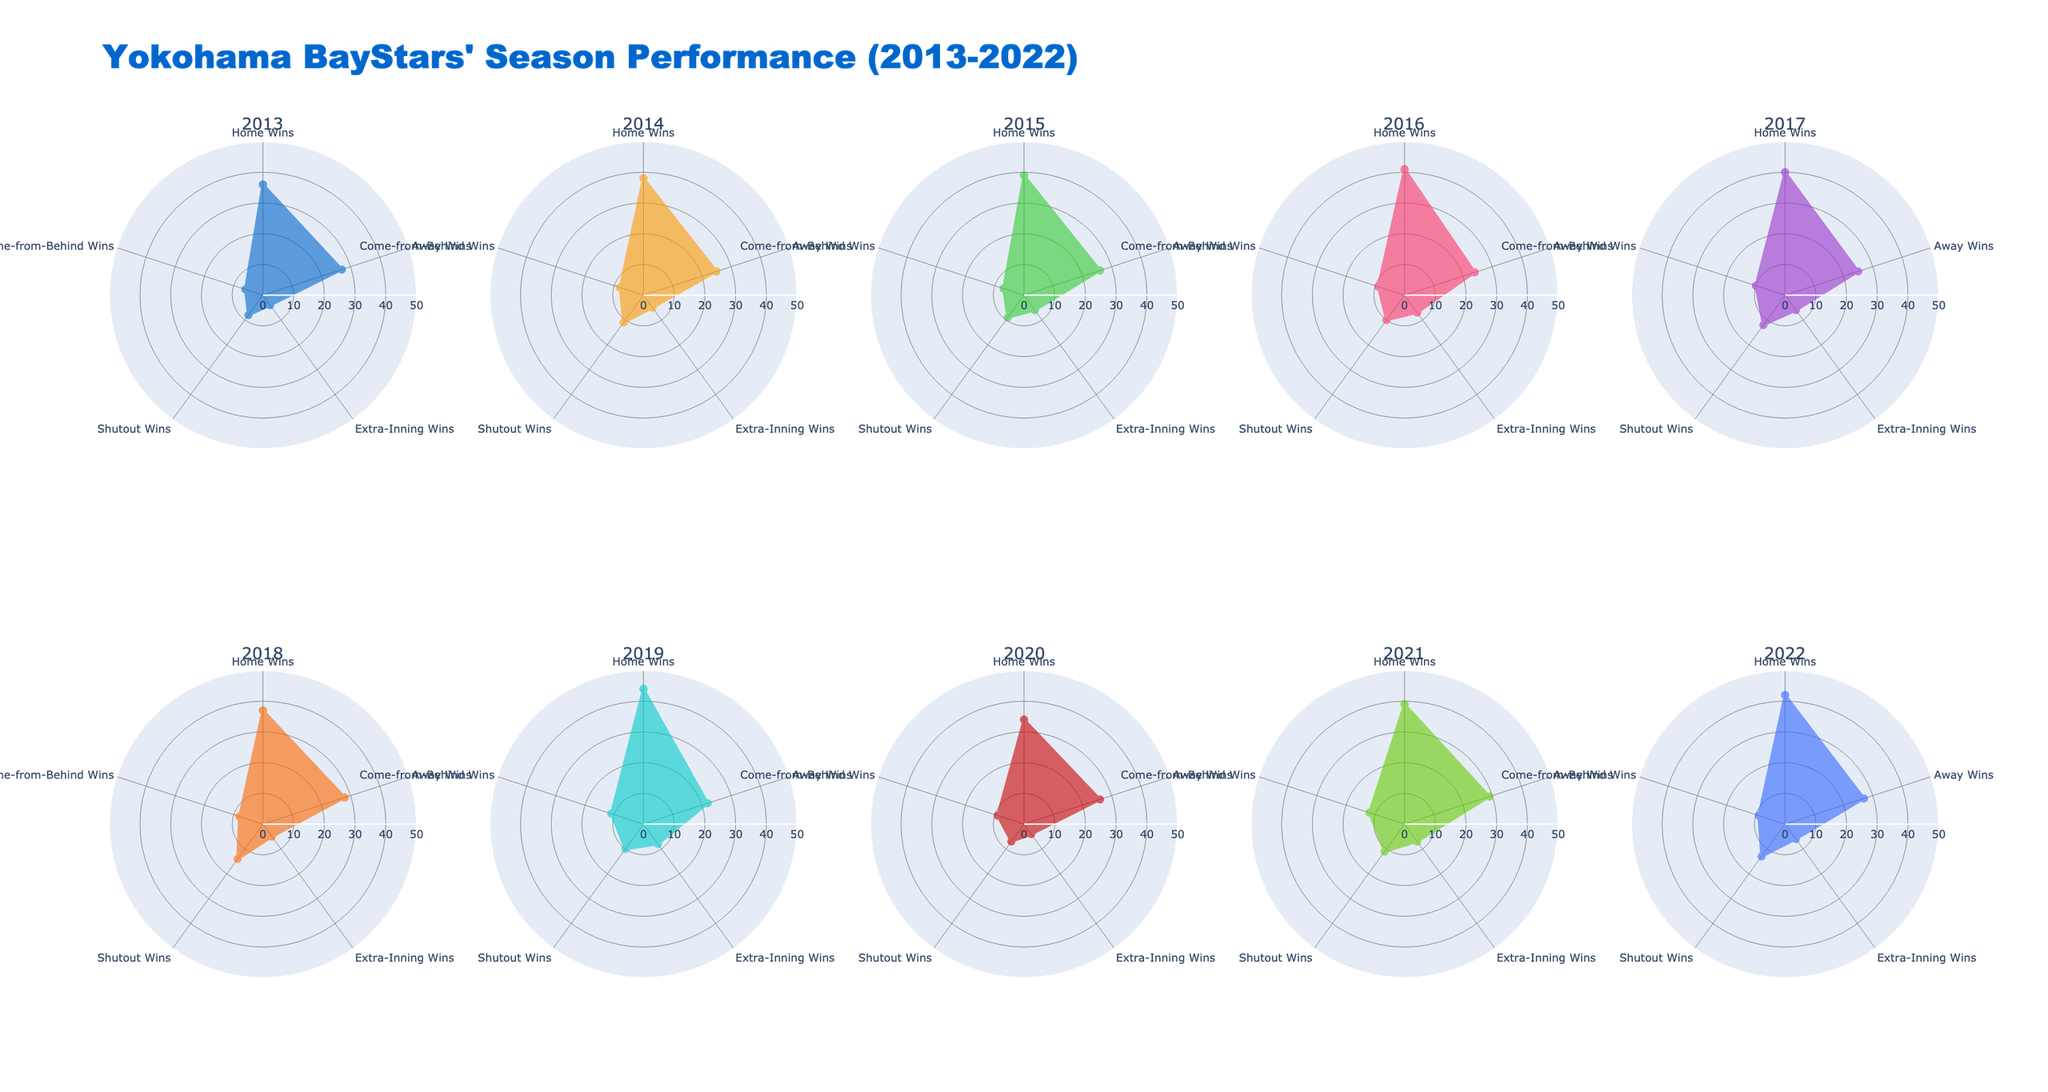What is the title of the figure? The title is prominently displayed at the top of the figure. It summarizes the overall content of the visualized data.
Answer: Yokohama BayStars' Season Performance (2013-2022) Which season had the highest number of Home Wins? By examining the individual radar charts, we can identify the chart with the highest value on the 'Home Wins' axis.
Answer: 2019 In which season did Yokohama BayStars achieve fewer Away Wins compared to Home Wins? For each season, compare the values on the 'Home Wins' and 'Away Wins' axes in their respective radar charts.
Answer: All seasons What is the total number of Extra-Inning Wins across all seasons? Sum up the 'Extra-Inning Wins' values across all radar charts. The values are (4 + 5 + 6 + 7 + 6 + 5 + 8 + 4 + 7 + 6).
Answer: 58 During which season did Yokohama BayStars record the highest number of Shutout Wins? Identify the radar chart with the highest value on the 'Shutout Wins' axis.
Answer: 2018 How does the number of Come-from-Behind Wins in 2021 compare to 2014? Compare the values of 'Come-from-Behind Wins' in the radar charts for the seasons 2021 and 2014.
Answer: 2021 has more than 2014 Which seasons are represented by radar charts with a primary color of blue? Identify the radar charts using blue as the main fill color, referring to specific seasons.
Answer: 2013, 2022 What is the average number of Shutout Wins in the decade? Calculate the sum of 'Shutout Wins' across all seasons, then divide by the number of seasons (10). The values are (8 + 11 + 9 + 10 + 12 + 14 + 10 + 7 + 11 + 13).
Answer: 10.5 In terms of Extra-Inning Wins, which two consecutive seasons show the biggest increase? For each pair of consecutive seasons, subtract the earlier season's 'Extra-Inning Wins' from the later season's.
Answer: 2015 to 2016 How many seasons had equal or more Come-from-Behind Wins than Shutout Wins? Compare the values of 'Come-from-Behind Wins' and 'Shutout Wins' across all radar charts to count the qualifying seasons.
Answer: 6 